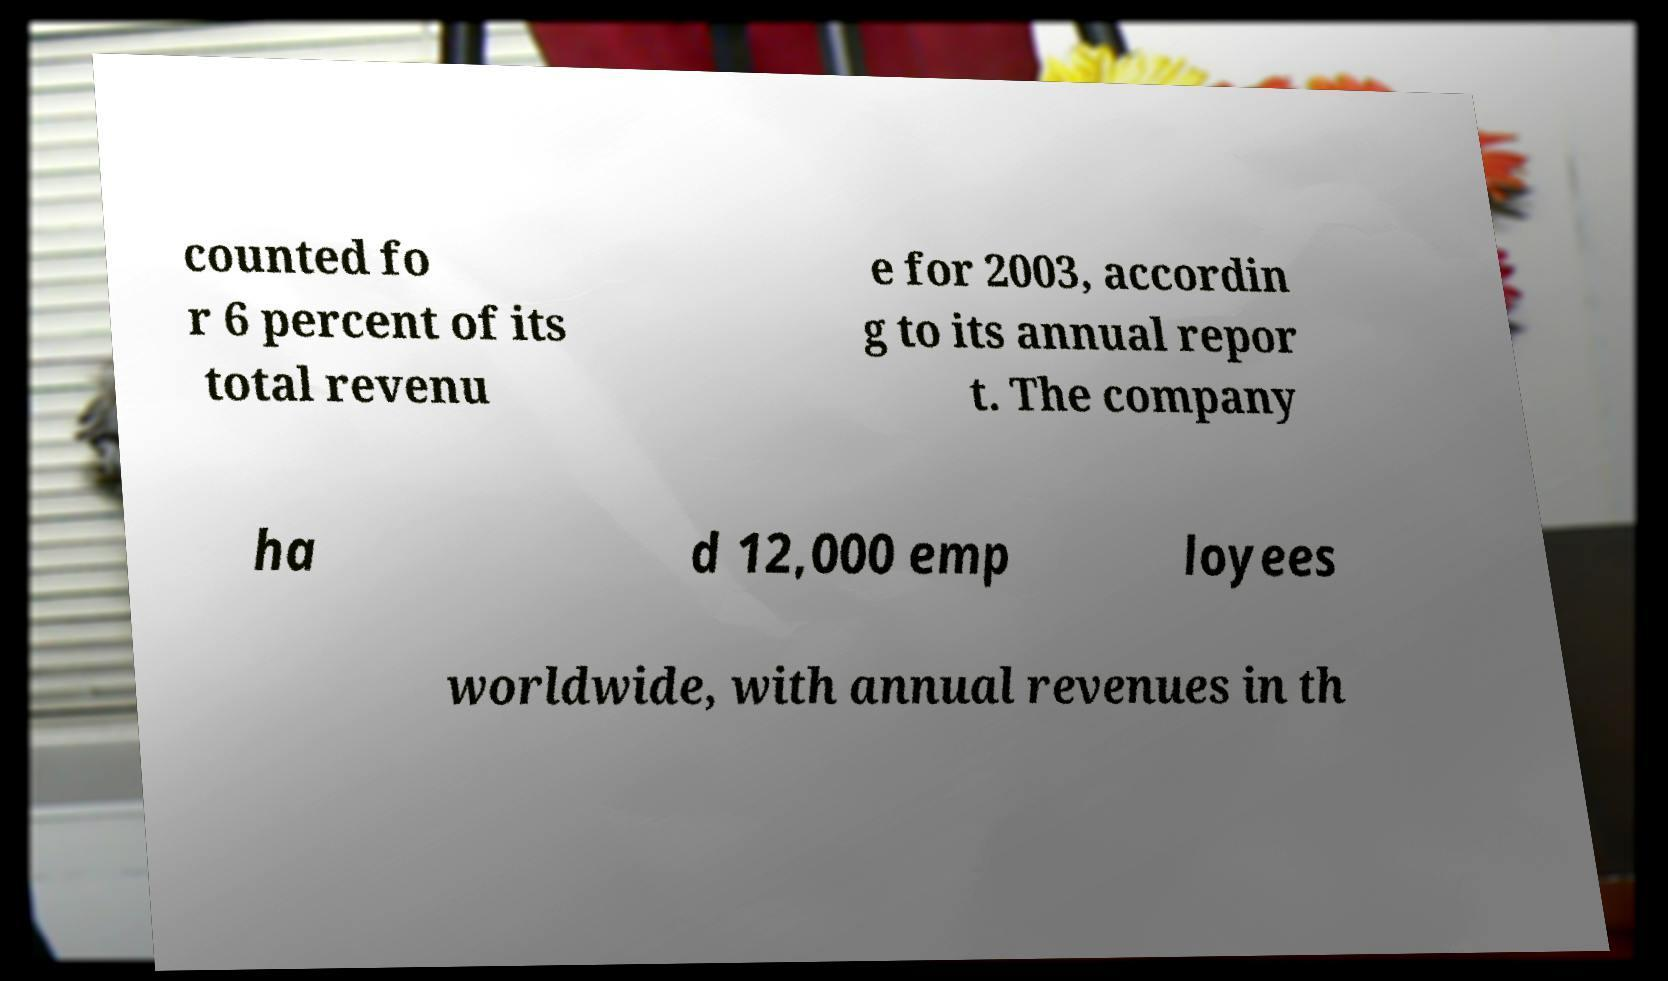Could you assist in decoding the text presented in this image and type it out clearly? counted fo r 6 percent of its total revenu e for 2003, accordin g to its annual repor t. The company ha d 12,000 emp loyees worldwide, with annual revenues in th 